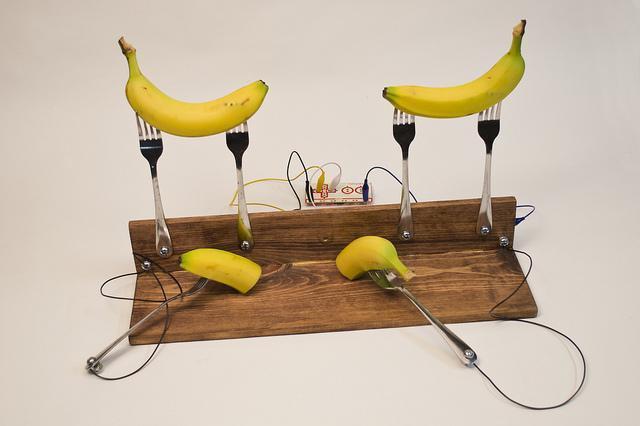How many forks are upright?
Give a very brief answer. 4. How many bananas are visible?
Give a very brief answer. 4. 